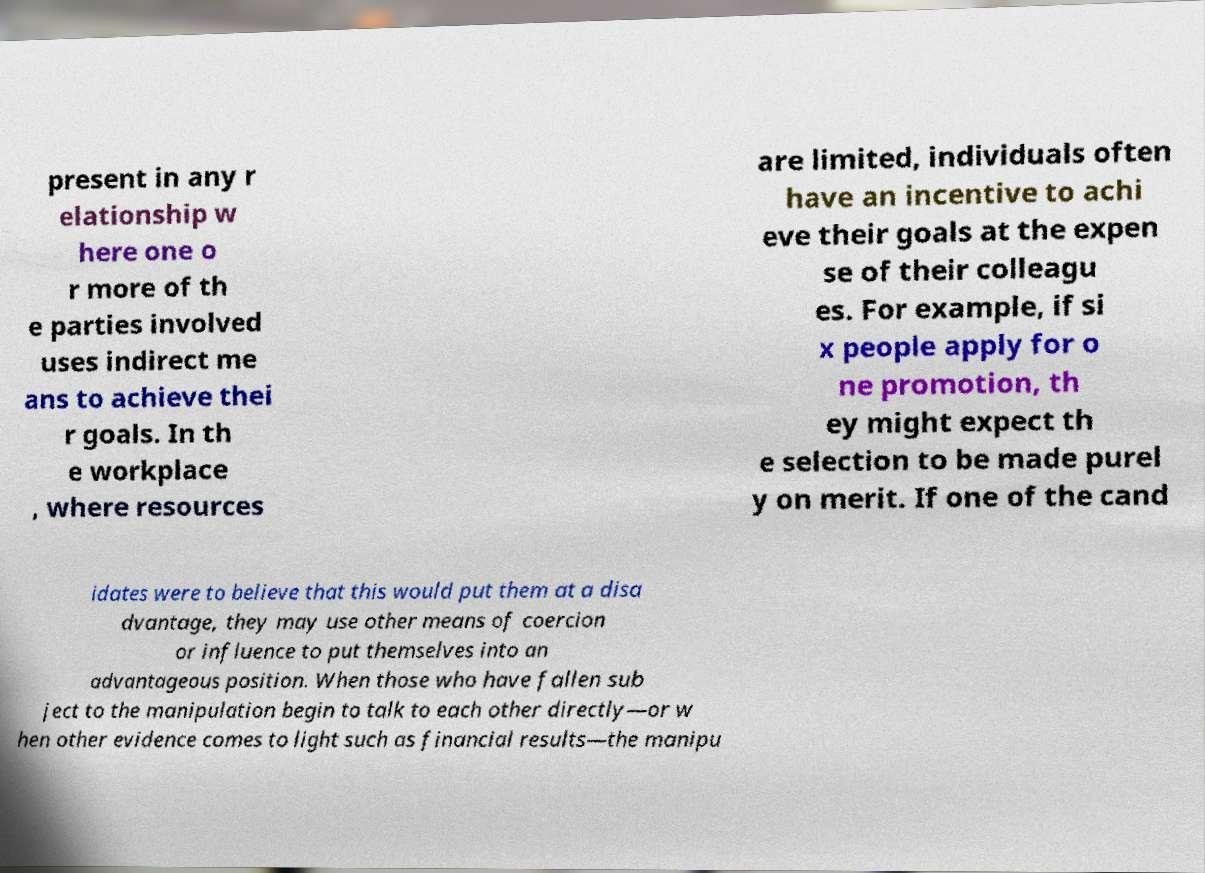Please identify and transcribe the text found in this image. present in any r elationship w here one o r more of th e parties involved uses indirect me ans to achieve thei r goals. In th e workplace , where resources are limited, individuals often have an incentive to achi eve their goals at the expen se of their colleagu es. For example, if si x people apply for o ne promotion, th ey might expect th e selection to be made purel y on merit. If one of the cand idates were to believe that this would put them at a disa dvantage, they may use other means of coercion or influence to put themselves into an advantageous position. When those who have fallen sub ject to the manipulation begin to talk to each other directly—or w hen other evidence comes to light such as financial results—the manipu 